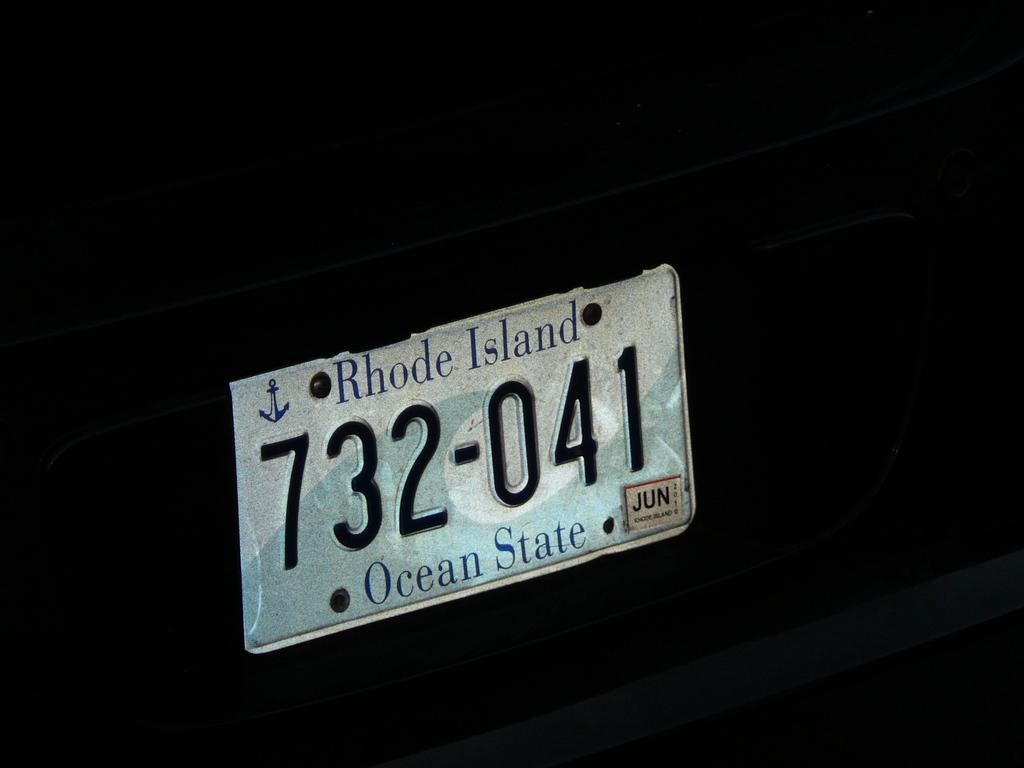What is the main object in the image? There is a board in the image. What is written or displayed on the board? There is text and numbers on the board. How many cats are in the image? There are no cats present in the image; it only features a board with text and numbers. 